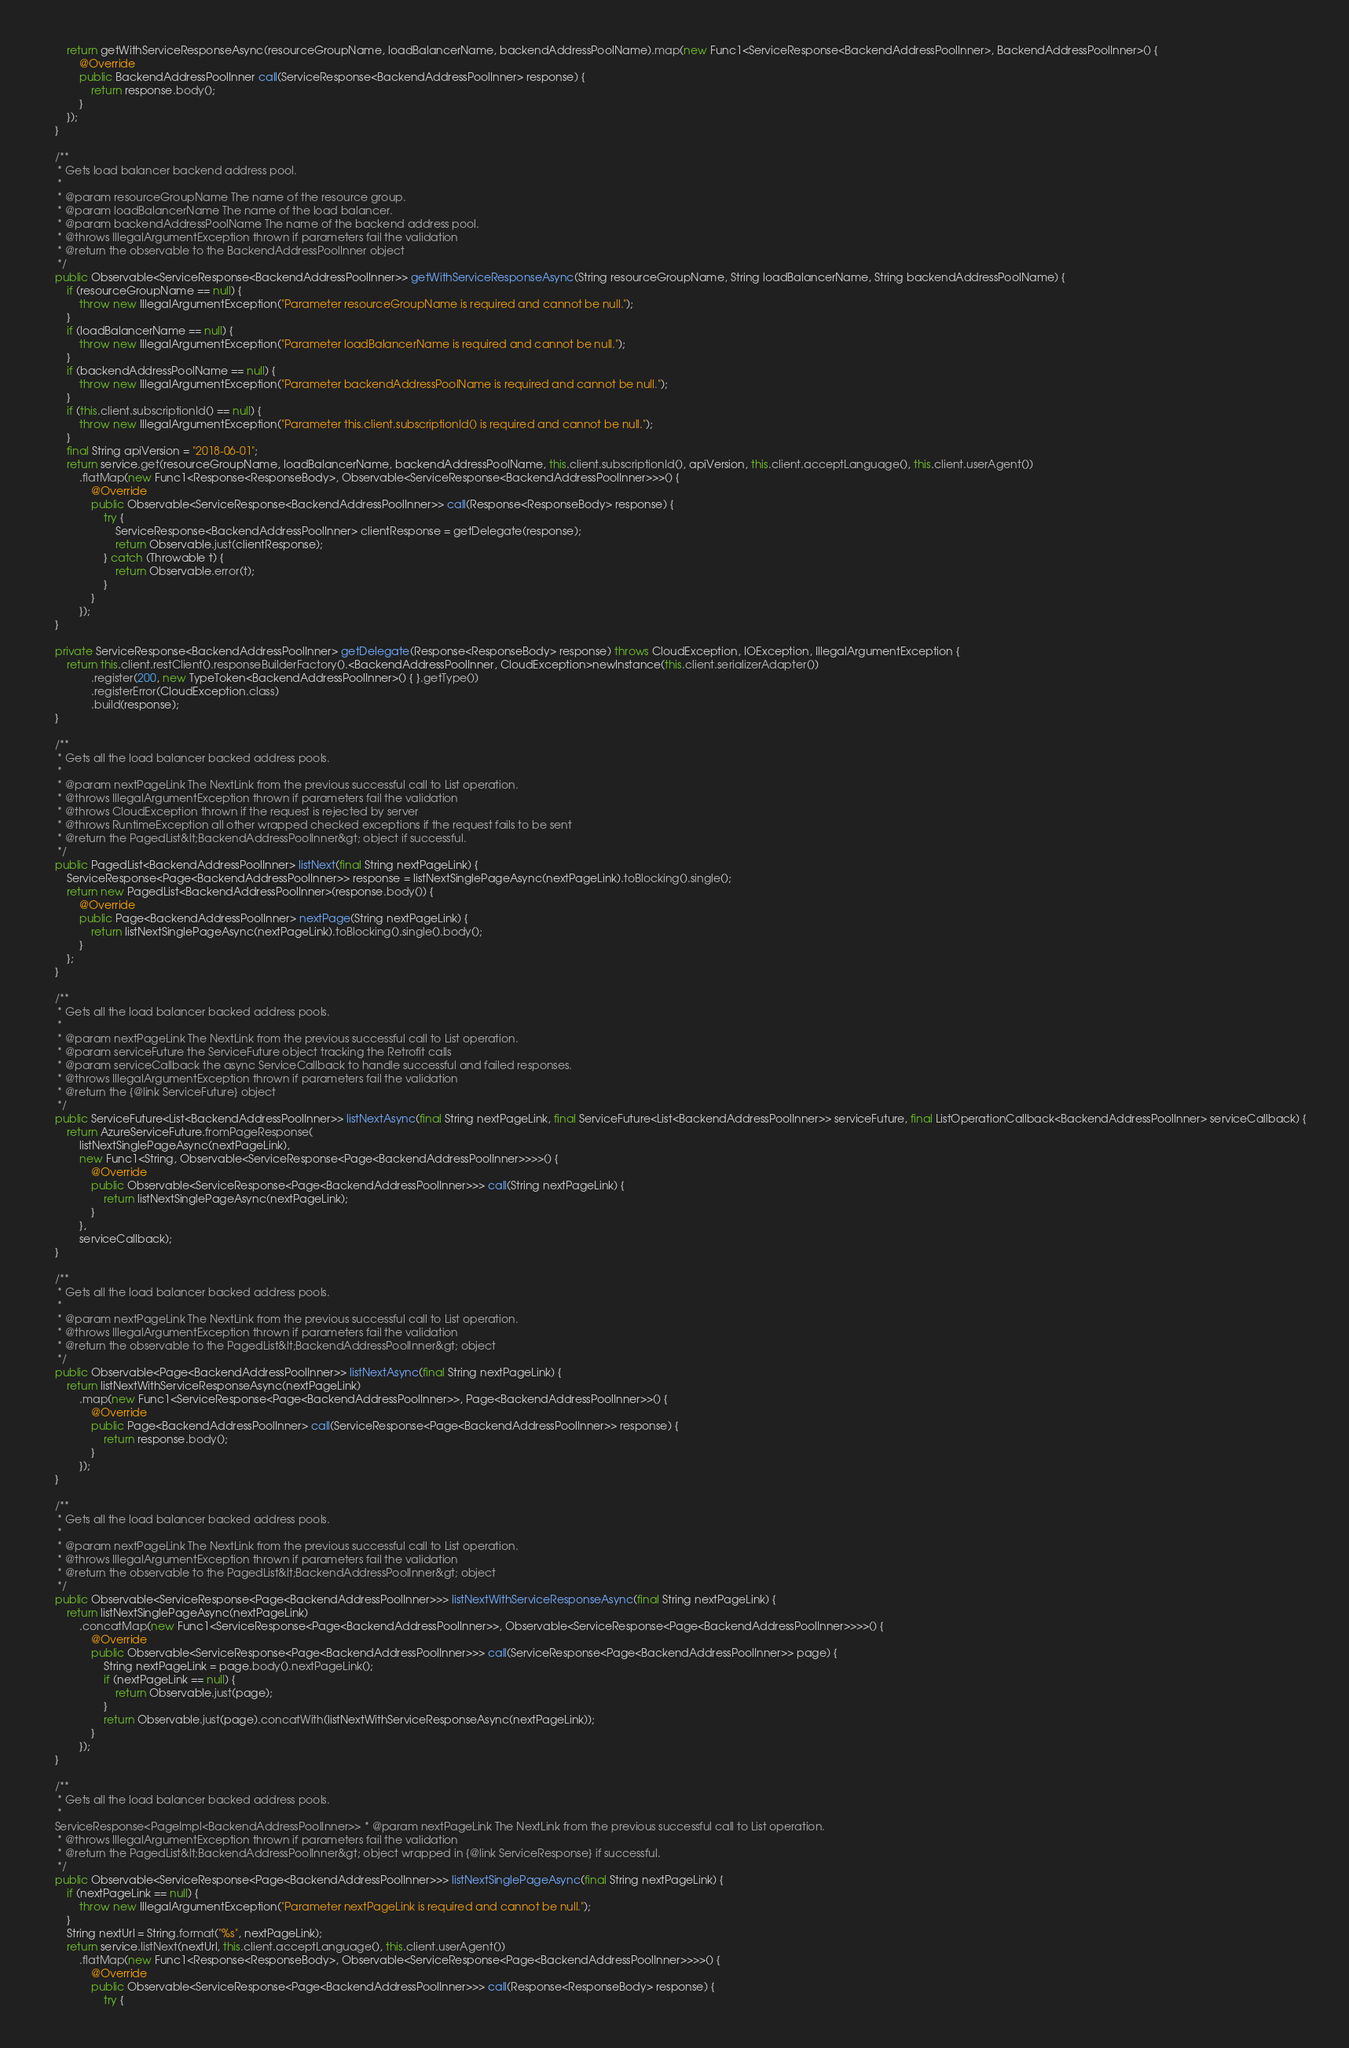Convert code to text. <code><loc_0><loc_0><loc_500><loc_500><_Java_>        return getWithServiceResponseAsync(resourceGroupName, loadBalancerName, backendAddressPoolName).map(new Func1<ServiceResponse<BackendAddressPoolInner>, BackendAddressPoolInner>() {
            @Override
            public BackendAddressPoolInner call(ServiceResponse<BackendAddressPoolInner> response) {
                return response.body();
            }
        });
    }

    /**
     * Gets load balancer backend address pool.
     *
     * @param resourceGroupName The name of the resource group.
     * @param loadBalancerName The name of the load balancer.
     * @param backendAddressPoolName The name of the backend address pool.
     * @throws IllegalArgumentException thrown if parameters fail the validation
     * @return the observable to the BackendAddressPoolInner object
     */
    public Observable<ServiceResponse<BackendAddressPoolInner>> getWithServiceResponseAsync(String resourceGroupName, String loadBalancerName, String backendAddressPoolName) {
        if (resourceGroupName == null) {
            throw new IllegalArgumentException("Parameter resourceGroupName is required and cannot be null.");
        }
        if (loadBalancerName == null) {
            throw new IllegalArgumentException("Parameter loadBalancerName is required and cannot be null.");
        }
        if (backendAddressPoolName == null) {
            throw new IllegalArgumentException("Parameter backendAddressPoolName is required and cannot be null.");
        }
        if (this.client.subscriptionId() == null) {
            throw new IllegalArgumentException("Parameter this.client.subscriptionId() is required and cannot be null.");
        }
        final String apiVersion = "2018-06-01";
        return service.get(resourceGroupName, loadBalancerName, backendAddressPoolName, this.client.subscriptionId(), apiVersion, this.client.acceptLanguage(), this.client.userAgent())
            .flatMap(new Func1<Response<ResponseBody>, Observable<ServiceResponse<BackendAddressPoolInner>>>() {
                @Override
                public Observable<ServiceResponse<BackendAddressPoolInner>> call(Response<ResponseBody> response) {
                    try {
                        ServiceResponse<BackendAddressPoolInner> clientResponse = getDelegate(response);
                        return Observable.just(clientResponse);
                    } catch (Throwable t) {
                        return Observable.error(t);
                    }
                }
            });
    }

    private ServiceResponse<BackendAddressPoolInner> getDelegate(Response<ResponseBody> response) throws CloudException, IOException, IllegalArgumentException {
        return this.client.restClient().responseBuilderFactory().<BackendAddressPoolInner, CloudException>newInstance(this.client.serializerAdapter())
                .register(200, new TypeToken<BackendAddressPoolInner>() { }.getType())
                .registerError(CloudException.class)
                .build(response);
    }

    /**
     * Gets all the load balancer backed address pools.
     *
     * @param nextPageLink The NextLink from the previous successful call to List operation.
     * @throws IllegalArgumentException thrown if parameters fail the validation
     * @throws CloudException thrown if the request is rejected by server
     * @throws RuntimeException all other wrapped checked exceptions if the request fails to be sent
     * @return the PagedList&lt;BackendAddressPoolInner&gt; object if successful.
     */
    public PagedList<BackendAddressPoolInner> listNext(final String nextPageLink) {
        ServiceResponse<Page<BackendAddressPoolInner>> response = listNextSinglePageAsync(nextPageLink).toBlocking().single();
        return new PagedList<BackendAddressPoolInner>(response.body()) {
            @Override
            public Page<BackendAddressPoolInner> nextPage(String nextPageLink) {
                return listNextSinglePageAsync(nextPageLink).toBlocking().single().body();
            }
        };
    }

    /**
     * Gets all the load balancer backed address pools.
     *
     * @param nextPageLink The NextLink from the previous successful call to List operation.
     * @param serviceFuture the ServiceFuture object tracking the Retrofit calls
     * @param serviceCallback the async ServiceCallback to handle successful and failed responses.
     * @throws IllegalArgumentException thrown if parameters fail the validation
     * @return the {@link ServiceFuture} object
     */
    public ServiceFuture<List<BackendAddressPoolInner>> listNextAsync(final String nextPageLink, final ServiceFuture<List<BackendAddressPoolInner>> serviceFuture, final ListOperationCallback<BackendAddressPoolInner> serviceCallback) {
        return AzureServiceFuture.fromPageResponse(
            listNextSinglePageAsync(nextPageLink),
            new Func1<String, Observable<ServiceResponse<Page<BackendAddressPoolInner>>>>() {
                @Override
                public Observable<ServiceResponse<Page<BackendAddressPoolInner>>> call(String nextPageLink) {
                    return listNextSinglePageAsync(nextPageLink);
                }
            },
            serviceCallback);
    }

    /**
     * Gets all the load balancer backed address pools.
     *
     * @param nextPageLink The NextLink from the previous successful call to List operation.
     * @throws IllegalArgumentException thrown if parameters fail the validation
     * @return the observable to the PagedList&lt;BackendAddressPoolInner&gt; object
     */
    public Observable<Page<BackendAddressPoolInner>> listNextAsync(final String nextPageLink) {
        return listNextWithServiceResponseAsync(nextPageLink)
            .map(new Func1<ServiceResponse<Page<BackendAddressPoolInner>>, Page<BackendAddressPoolInner>>() {
                @Override
                public Page<BackendAddressPoolInner> call(ServiceResponse<Page<BackendAddressPoolInner>> response) {
                    return response.body();
                }
            });
    }

    /**
     * Gets all the load balancer backed address pools.
     *
     * @param nextPageLink The NextLink from the previous successful call to List operation.
     * @throws IllegalArgumentException thrown if parameters fail the validation
     * @return the observable to the PagedList&lt;BackendAddressPoolInner&gt; object
     */
    public Observable<ServiceResponse<Page<BackendAddressPoolInner>>> listNextWithServiceResponseAsync(final String nextPageLink) {
        return listNextSinglePageAsync(nextPageLink)
            .concatMap(new Func1<ServiceResponse<Page<BackendAddressPoolInner>>, Observable<ServiceResponse<Page<BackendAddressPoolInner>>>>() {
                @Override
                public Observable<ServiceResponse<Page<BackendAddressPoolInner>>> call(ServiceResponse<Page<BackendAddressPoolInner>> page) {
                    String nextPageLink = page.body().nextPageLink();
                    if (nextPageLink == null) {
                        return Observable.just(page);
                    }
                    return Observable.just(page).concatWith(listNextWithServiceResponseAsync(nextPageLink));
                }
            });
    }

    /**
     * Gets all the load balancer backed address pools.
     *
    ServiceResponse<PageImpl<BackendAddressPoolInner>> * @param nextPageLink The NextLink from the previous successful call to List operation.
     * @throws IllegalArgumentException thrown if parameters fail the validation
     * @return the PagedList&lt;BackendAddressPoolInner&gt; object wrapped in {@link ServiceResponse} if successful.
     */
    public Observable<ServiceResponse<Page<BackendAddressPoolInner>>> listNextSinglePageAsync(final String nextPageLink) {
        if (nextPageLink == null) {
            throw new IllegalArgumentException("Parameter nextPageLink is required and cannot be null.");
        }
        String nextUrl = String.format("%s", nextPageLink);
        return service.listNext(nextUrl, this.client.acceptLanguage(), this.client.userAgent())
            .flatMap(new Func1<Response<ResponseBody>, Observable<ServiceResponse<Page<BackendAddressPoolInner>>>>() {
                @Override
                public Observable<ServiceResponse<Page<BackendAddressPoolInner>>> call(Response<ResponseBody> response) {
                    try {</code> 